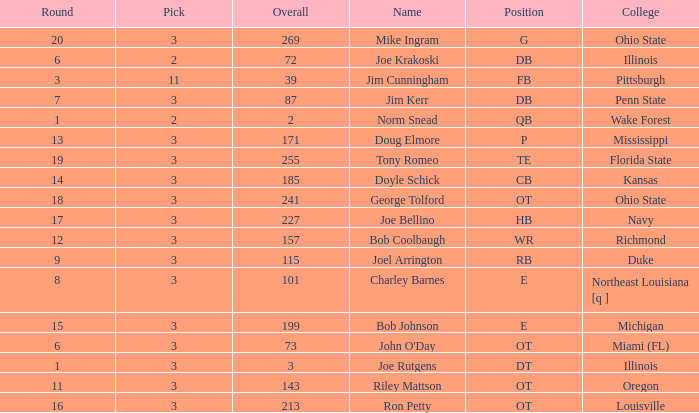How many overalls have charley barnes as the name, with a pick less than 3? None. 